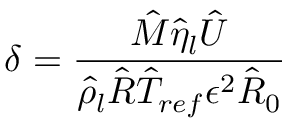Convert formula to latex. <formula><loc_0><loc_0><loc_500><loc_500>\delta = \frac { \hat { M } \hat { \eta } _ { l } \hat { U } } { \hat { \rho } _ { l } \hat { R } \hat { T } _ { r e f } \epsilon ^ { 2 } \hat { R } _ { 0 } }</formula> 